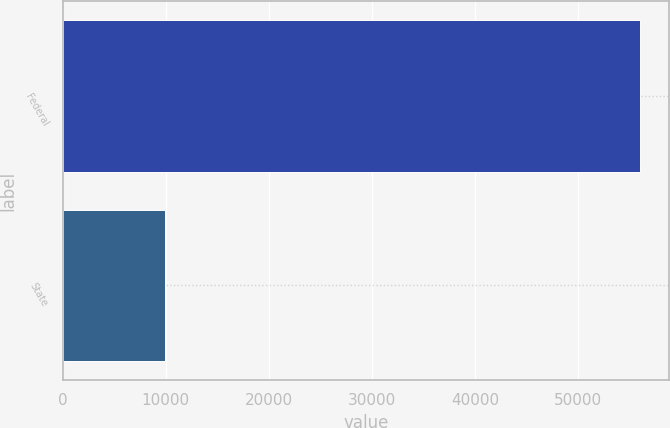<chart> <loc_0><loc_0><loc_500><loc_500><bar_chart><fcel>Federal<fcel>State<nl><fcel>56060<fcel>9948<nl></chart> 